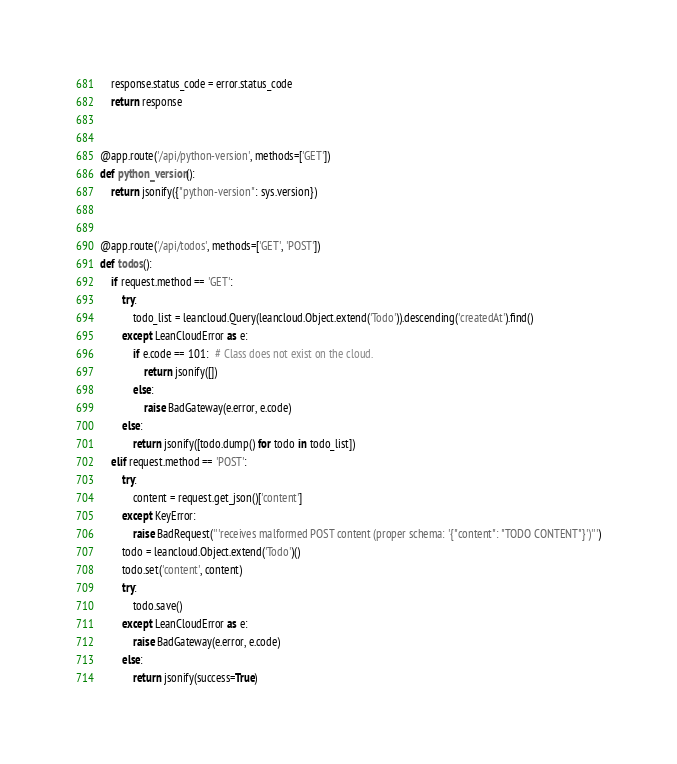Convert code to text. <code><loc_0><loc_0><loc_500><loc_500><_Python_>    response.status_code = error.status_code
    return response


@app.route('/api/python-version', methods=['GET'])
def python_version():
    return jsonify({"python-version": sys.version})


@app.route('/api/todos', methods=['GET', 'POST'])
def todos():
    if request.method == 'GET':
        try:
            todo_list = leancloud.Query(leancloud.Object.extend('Todo')).descending('createdAt').find()
        except LeanCloudError as e:
            if e.code == 101:  # Class does not exist on the cloud.
                return jsonify([])
            else:
                raise BadGateway(e.error, e.code)
        else:
            return jsonify([todo.dump() for todo in todo_list])
    elif request.method == 'POST':
        try:
            content = request.get_json()['content']
        except KeyError:
            raise BadRequest('''receives malformed POST content (proper schema: '{"content": "TODO CONTENT"}')''')
        todo = leancloud.Object.extend('Todo')()
        todo.set('content', content)
        try:
            todo.save()
        except LeanCloudError as e:
            raise BadGateway(e.error, e.code)
        else:
            return jsonify(success=True)
</code> 